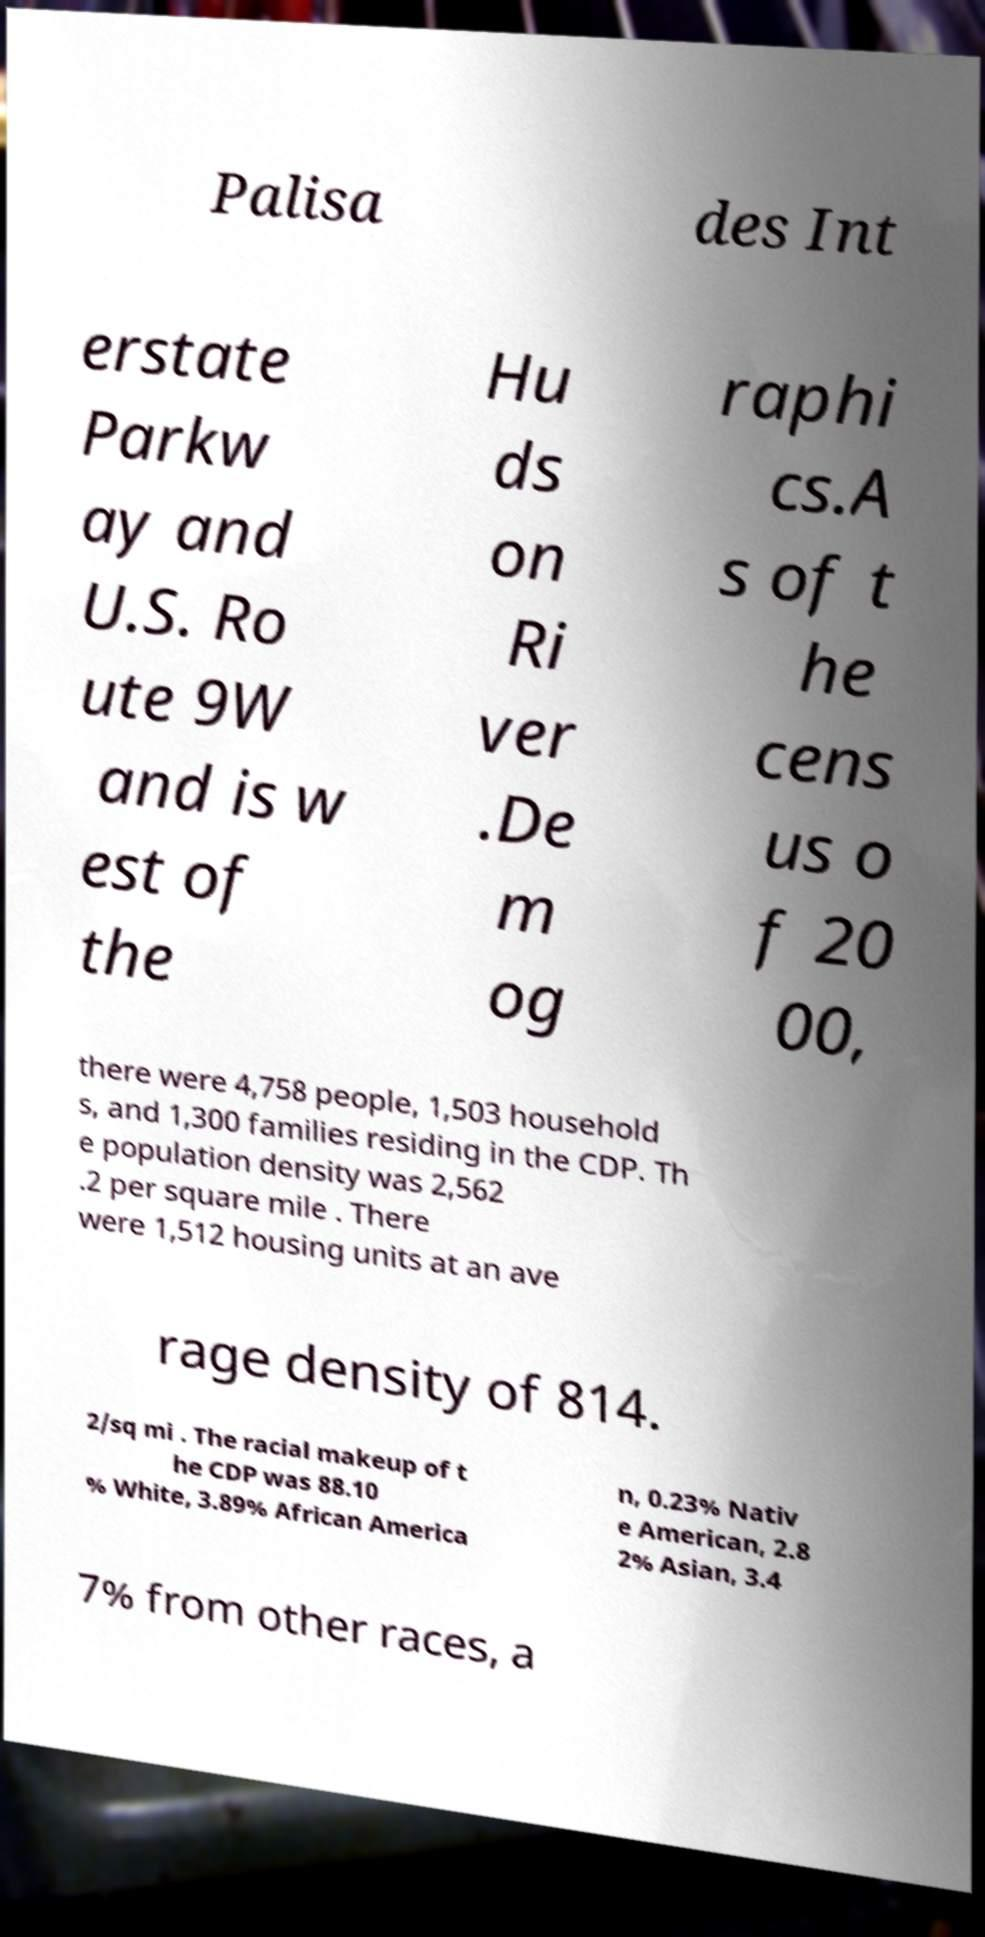Please read and relay the text visible in this image. What does it say? Palisa des Int erstate Parkw ay and U.S. Ro ute 9W and is w est of the Hu ds on Ri ver .De m og raphi cs.A s of t he cens us o f 20 00, there were 4,758 people, 1,503 household s, and 1,300 families residing in the CDP. Th e population density was 2,562 .2 per square mile . There were 1,512 housing units at an ave rage density of 814. 2/sq mi . The racial makeup of t he CDP was 88.10 % White, 3.89% African America n, 0.23% Nativ e American, 2.8 2% Asian, 3.4 7% from other races, a 